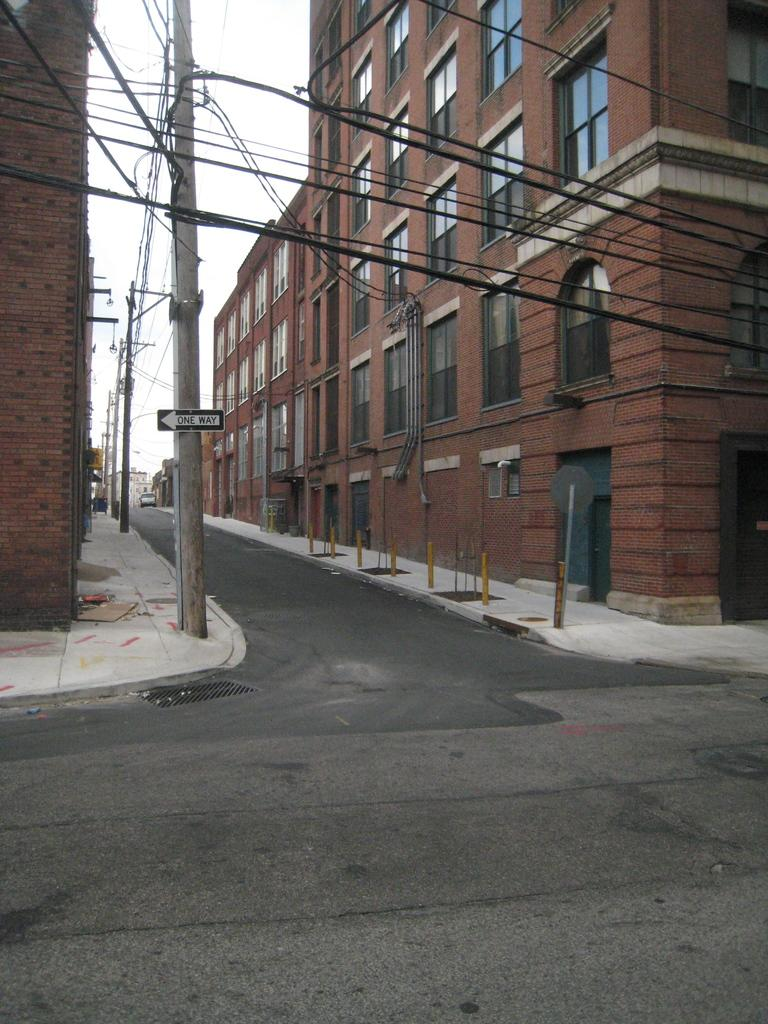What is the main feature of the image? There is a way or path in the image. What can be seen on either side of the way? There are buildings on either side of the way. Where are the poles and wires located in the image? The poles and wires are in the left corner of the image. Can you see a jail or a mountain in the image? No, there is no jail or mountain present in the image. Is there a rifle visible in the image? No, there is no rifle visible in the image. 